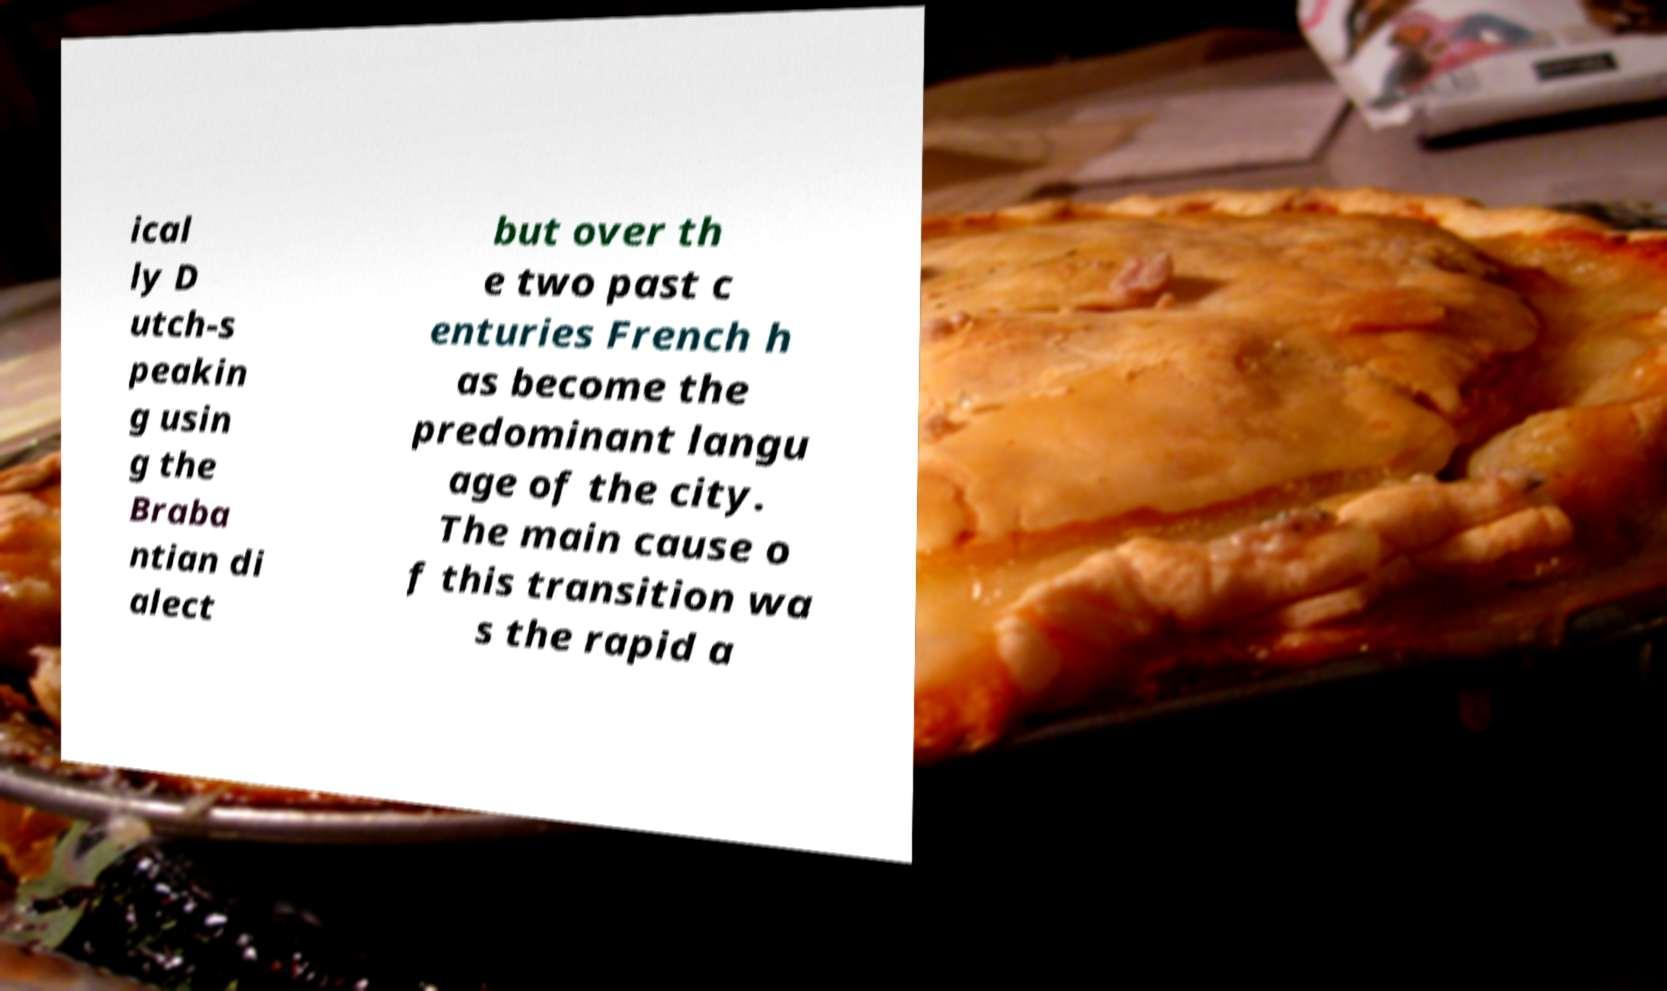Could you assist in decoding the text presented in this image and type it out clearly? ical ly D utch-s peakin g usin g the Braba ntian di alect but over th e two past c enturies French h as become the predominant langu age of the city. The main cause o f this transition wa s the rapid a 